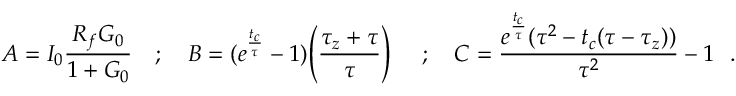<formula> <loc_0><loc_0><loc_500><loc_500>A = I _ { 0 } \frac { R _ { f } G _ { 0 } } { 1 + G _ { 0 } } ; B = ( e ^ { \frac { t _ { c } } { \tau } } - 1 ) \left ( \frac { \tau _ { z } + \tau } { \tau } \right ) ; C = \frac { e ^ { \frac { t _ { c } } { \tau } } ( \tau ^ { 2 } - t _ { c } ( \tau - \tau _ { z } ) ) } { \tau ^ { 2 } } - 1 .</formula> 